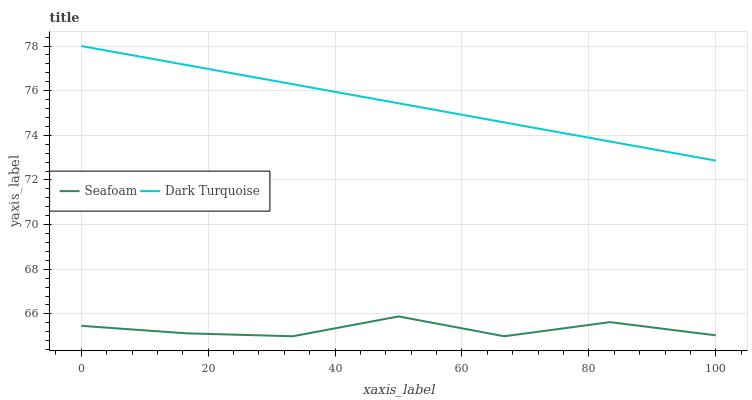Does Seafoam have the minimum area under the curve?
Answer yes or no. Yes. Does Dark Turquoise have the maximum area under the curve?
Answer yes or no. Yes. Does Seafoam have the maximum area under the curve?
Answer yes or no. No. Is Dark Turquoise the smoothest?
Answer yes or no. Yes. Is Seafoam the roughest?
Answer yes or no. Yes. Is Seafoam the smoothest?
Answer yes or no. No. Does Dark Turquoise have the highest value?
Answer yes or no. Yes. Does Seafoam have the highest value?
Answer yes or no. No. Is Seafoam less than Dark Turquoise?
Answer yes or no. Yes. Is Dark Turquoise greater than Seafoam?
Answer yes or no. Yes. Does Seafoam intersect Dark Turquoise?
Answer yes or no. No. 